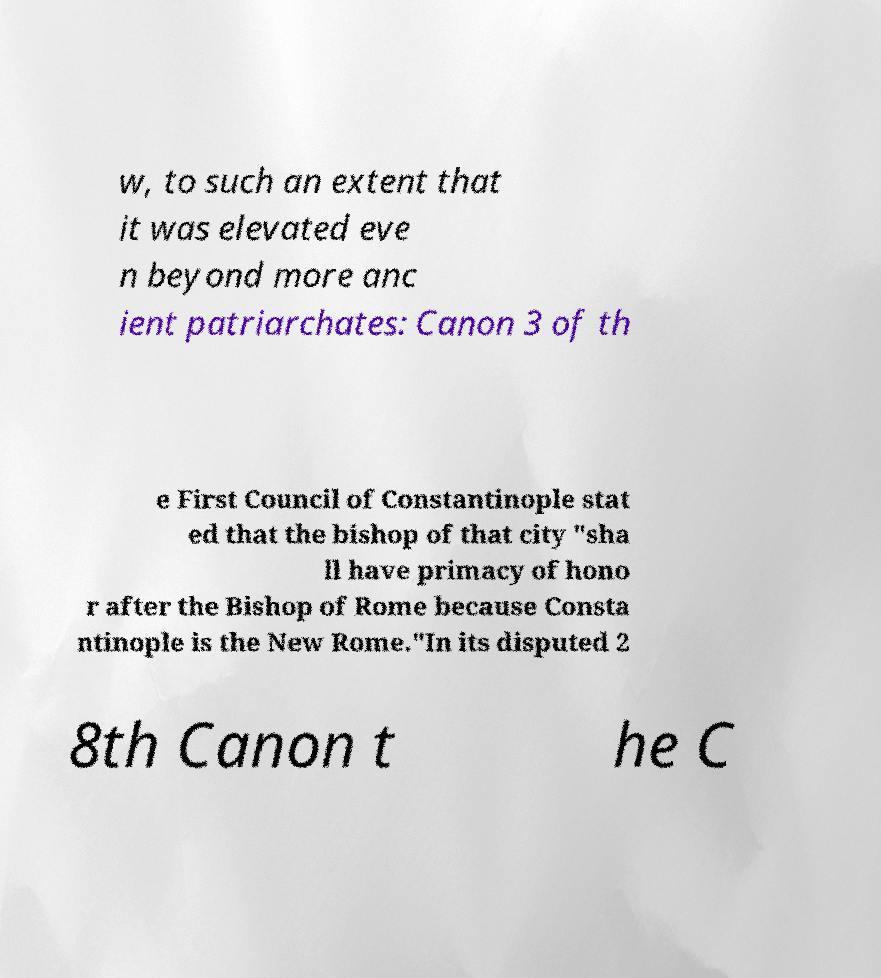There's text embedded in this image that I need extracted. Can you transcribe it verbatim? w, to such an extent that it was elevated eve n beyond more anc ient patriarchates: Canon 3 of th e First Council of Constantinople stat ed that the bishop of that city "sha ll have primacy of hono r after the Bishop of Rome because Consta ntinople is the New Rome."In its disputed 2 8th Canon t he C 